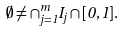Convert formula to latex. <formula><loc_0><loc_0><loc_500><loc_500>\emptyset \neq \cap _ { j = 1 } ^ { m } I _ { j } \cap [ 0 , 1 ] .</formula> 